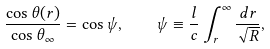Convert formula to latex. <formula><loc_0><loc_0><loc_500><loc_500>\frac { \cos \theta ( r ) } { \cos \theta _ { \infty } } = \cos \psi , \quad \psi \equiv \frac { l } { c } \int ^ { \infty } _ { r } \frac { d r } { \sqrt { R } } ,</formula> 